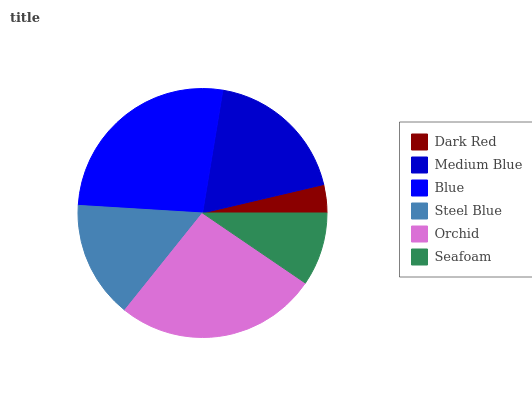Is Dark Red the minimum?
Answer yes or no. Yes. Is Blue the maximum?
Answer yes or no. Yes. Is Medium Blue the minimum?
Answer yes or no. No. Is Medium Blue the maximum?
Answer yes or no. No. Is Medium Blue greater than Dark Red?
Answer yes or no. Yes. Is Dark Red less than Medium Blue?
Answer yes or no. Yes. Is Dark Red greater than Medium Blue?
Answer yes or no. No. Is Medium Blue less than Dark Red?
Answer yes or no. No. Is Medium Blue the high median?
Answer yes or no. Yes. Is Steel Blue the low median?
Answer yes or no. Yes. Is Seafoam the high median?
Answer yes or no. No. Is Blue the low median?
Answer yes or no. No. 